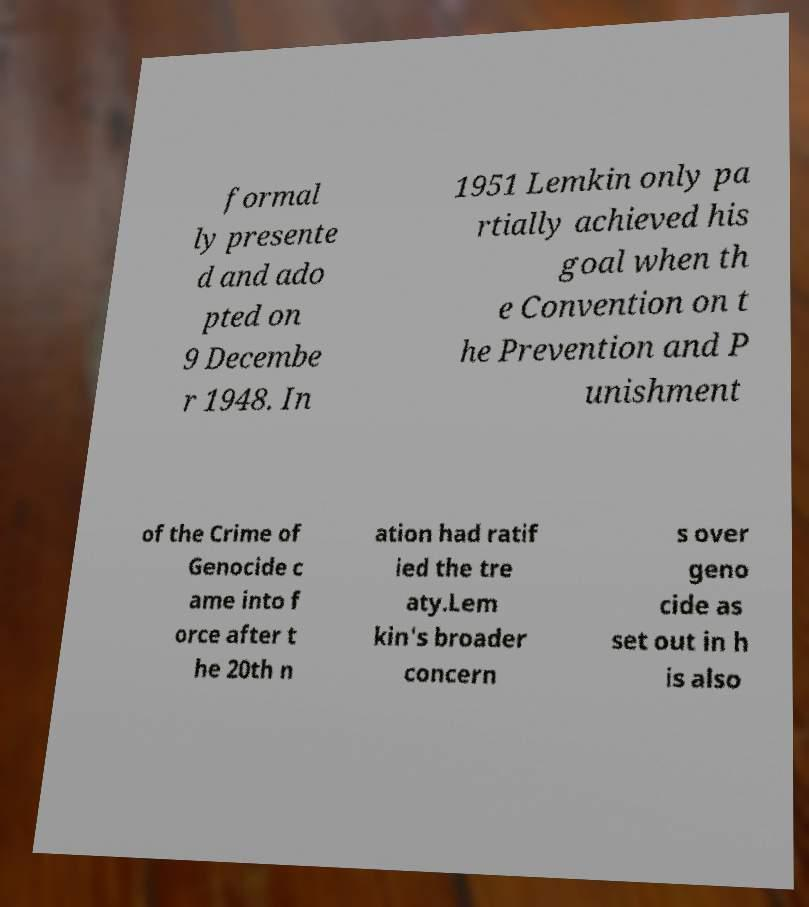I need the written content from this picture converted into text. Can you do that? formal ly presente d and ado pted on 9 Decembe r 1948. In 1951 Lemkin only pa rtially achieved his goal when th e Convention on t he Prevention and P unishment of the Crime of Genocide c ame into f orce after t he 20th n ation had ratif ied the tre aty.Lem kin's broader concern s over geno cide as set out in h is also 